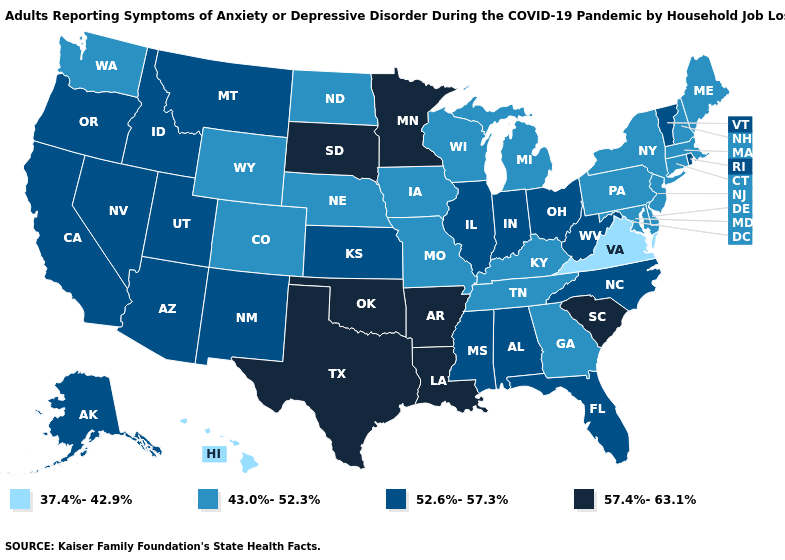What is the lowest value in the Northeast?
Write a very short answer. 43.0%-52.3%. Among the states that border Georgia , does South Carolina have the highest value?
Write a very short answer. Yes. Does Mississippi have the highest value in the USA?
Write a very short answer. No. Name the states that have a value in the range 43.0%-52.3%?
Quick response, please. Colorado, Connecticut, Delaware, Georgia, Iowa, Kentucky, Maine, Maryland, Massachusetts, Michigan, Missouri, Nebraska, New Hampshire, New Jersey, New York, North Dakota, Pennsylvania, Tennessee, Washington, Wisconsin, Wyoming. Among the states that border Colorado , which have the highest value?
Short answer required. Oklahoma. What is the highest value in the MidWest ?
Be succinct. 57.4%-63.1%. Does the first symbol in the legend represent the smallest category?
Answer briefly. Yes. What is the lowest value in states that border Tennessee?
Write a very short answer. 37.4%-42.9%. Which states have the lowest value in the USA?
Short answer required. Hawaii, Virginia. What is the highest value in the MidWest ?
Answer briefly. 57.4%-63.1%. What is the value of Florida?
Keep it brief. 52.6%-57.3%. What is the value of New Hampshire?
Answer briefly. 43.0%-52.3%. What is the value of West Virginia?
Short answer required. 52.6%-57.3%. What is the value of Kentucky?
Be succinct. 43.0%-52.3%. Does Tennessee have a lower value than New Hampshire?
Answer briefly. No. 